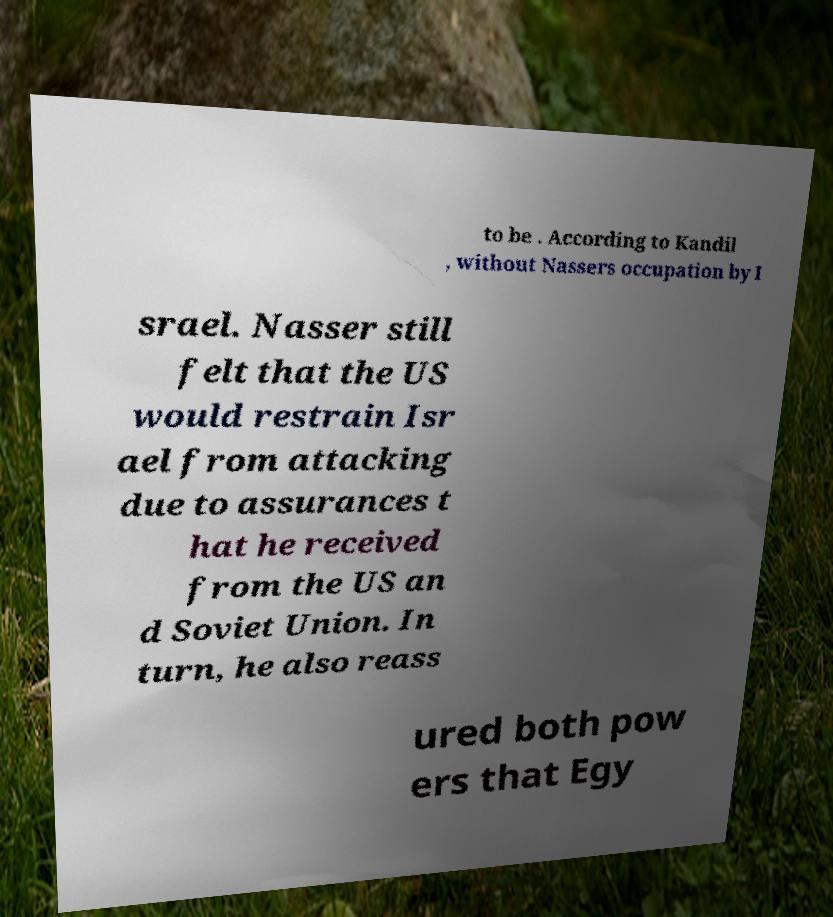What messages or text are displayed in this image? I need them in a readable, typed format. to be . According to Kandil , without Nassers occupation by I srael. Nasser still felt that the US would restrain Isr ael from attacking due to assurances t hat he received from the US an d Soviet Union. In turn, he also reass ured both pow ers that Egy 